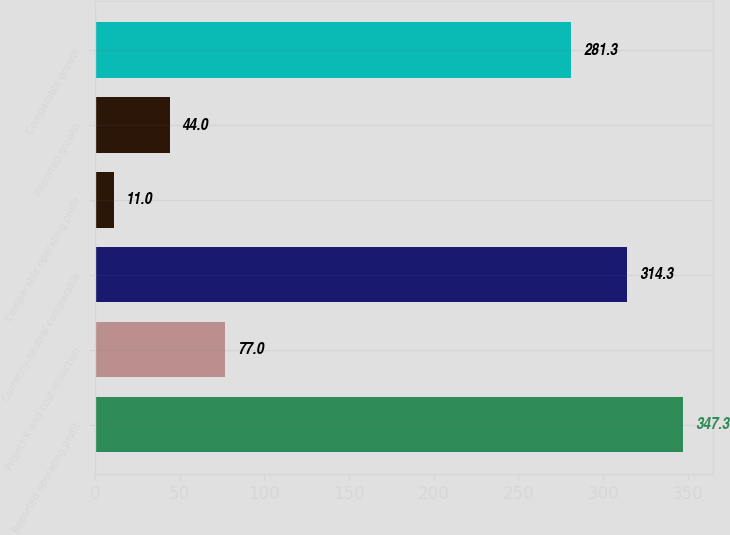Convert chart. <chart><loc_0><loc_0><loc_500><loc_500><bar_chart><fcel>Reported operating profit<fcel>Project K and cost reduction<fcel>Currency-neutral comparable<fcel>Comparable operating profit<fcel>Reported growth<fcel>Comparable growth<nl><fcel>347.3<fcel>77<fcel>314.3<fcel>11<fcel>44<fcel>281.3<nl></chart> 